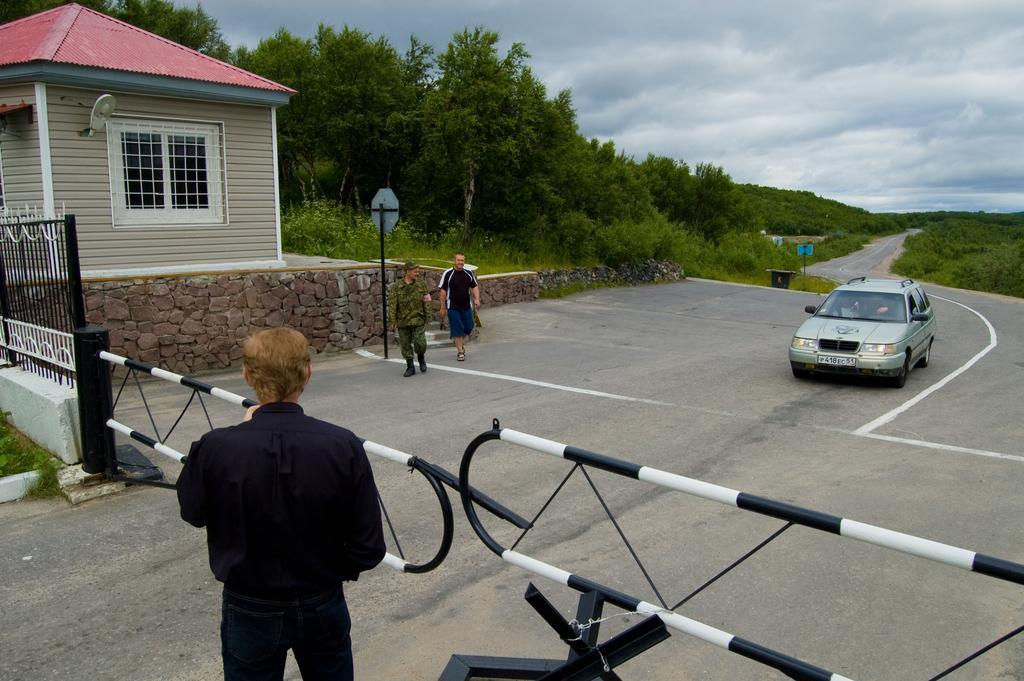Describe this image in one or two sentences. As we can see in the image there is a house, fence, few people here and there, sign pole, car, grass, trees, sky and clouds. 